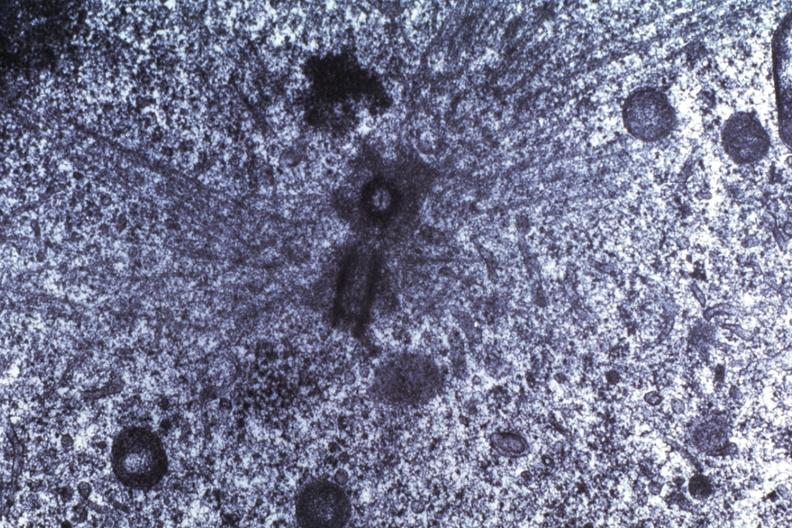what is present?
Answer the question using a single word or phrase. Medulloblastoma 